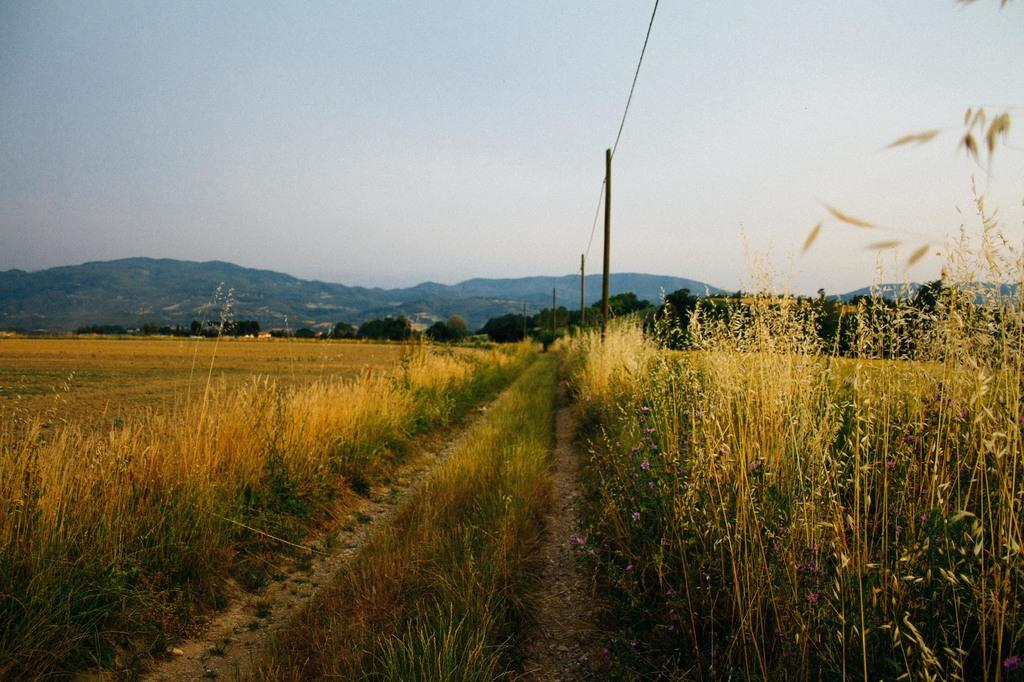What type of terrain is visible in the image? There is an open grass ground in the image. What other vegetation can be seen on the grass ground? There are bushes on the grass ground. What structures are visible in the background of the image? There are poles and trees in the background of the image. What natural features are visible in the background of the image? There are mountains and the sky visible in the background of the image. What level of difficulty is represented by the trick in the image? There is no trick present in the image; it is a scene of an open grass ground with bushes, poles, trees, mountains, and the sky visible in the background. 